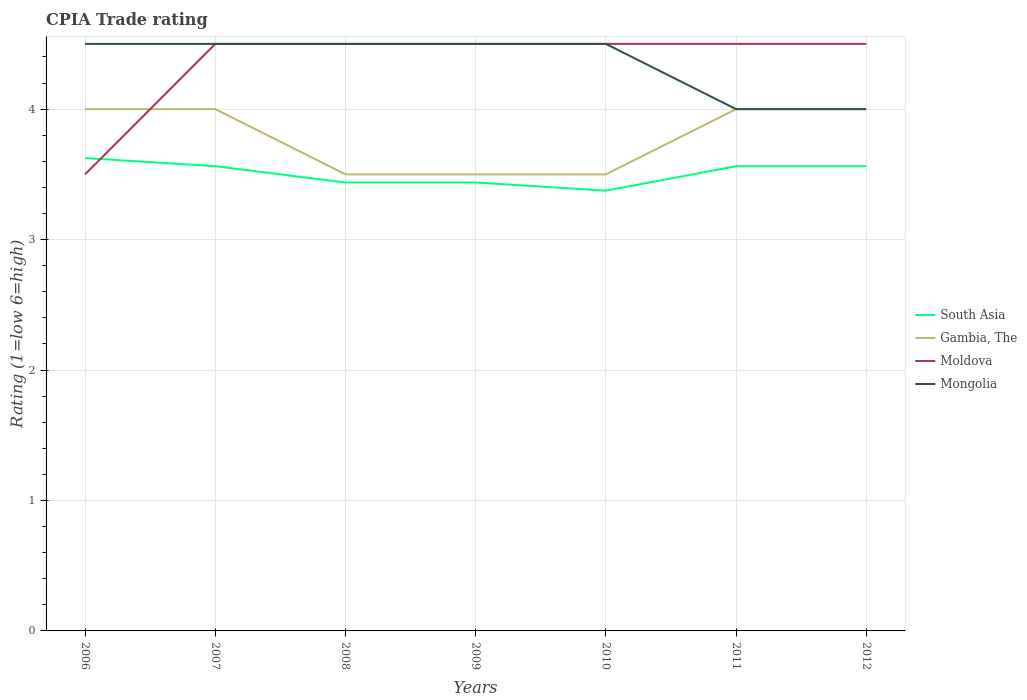Across all years, what is the maximum CPIA rating in Gambia, The?
Offer a very short reply. 3.5. In which year was the CPIA rating in Mongolia maximum?
Keep it short and to the point. 2011. What is the total CPIA rating in Mongolia in the graph?
Provide a succinct answer. 0. Is the CPIA rating in South Asia strictly greater than the CPIA rating in Mongolia over the years?
Give a very brief answer. Yes. How many lines are there?
Provide a succinct answer. 4. How many years are there in the graph?
Your answer should be compact. 7. What is the difference between two consecutive major ticks on the Y-axis?
Provide a succinct answer. 1. Are the values on the major ticks of Y-axis written in scientific E-notation?
Your answer should be very brief. No. What is the title of the graph?
Keep it short and to the point. CPIA Trade rating. Does "New Caledonia" appear as one of the legend labels in the graph?
Keep it short and to the point. No. What is the label or title of the X-axis?
Your response must be concise. Years. What is the Rating (1=low 6=high) of South Asia in 2006?
Provide a succinct answer. 3.62. What is the Rating (1=low 6=high) in South Asia in 2007?
Provide a short and direct response. 3.56. What is the Rating (1=low 6=high) in Moldova in 2007?
Give a very brief answer. 4.5. What is the Rating (1=low 6=high) in South Asia in 2008?
Provide a short and direct response. 3.44. What is the Rating (1=low 6=high) of Gambia, The in 2008?
Provide a short and direct response. 3.5. What is the Rating (1=low 6=high) of South Asia in 2009?
Your response must be concise. 3.44. What is the Rating (1=low 6=high) in Moldova in 2009?
Provide a succinct answer. 4.5. What is the Rating (1=low 6=high) of Mongolia in 2009?
Your answer should be compact. 4.5. What is the Rating (1=low 6=high) in South Asia in 2010?
Offer a very short reply. 3.38. What is the Rating (1=low 6=high) of South Asia in 2011?
Your response must be concise. 3.56. What is the Rating (1=low 6=high) in South Asia in 2012?
Provide a succinct answer. 3.56. What is the Rating (1=low 6=high) of Gambia, The in 2012?
Your answer should be very brief. 4. What is the Rating (1=low 6=high) in Mongolia in 2012?
Provide a short and direct response. 4. Across all years, what is the maximum Rating (1=low 6=high) of South Asia?
Keep it short and to the point. 3.62. Across all years, what is the maximum Rating (1=low 6=high) of Gambia, The?
Make the answer very short. 4. Across all years, what is the maximum Rating (1=low 6=high) of Moldova?
Provide a short and direct response. 4.5. Across all years, what is the minimum Rating (1=low 6=high) of South Asia?
Make the answer very short. 3.38. What is the total Rating (1=low 6=high) of South Asia in the graph?
Your response must be concise. 24.56. What is the total Rating (1=low 6=high) of Moldova in the graph?
Provide a succinct answer. 30.5. What is the total Rating (1=low 6=high) of Mongolia in the graph?
Give a very brief answer. 30.5. What is the difference between the Rating (1=low 6=high) in South Asia in 2006 and that in 2007?
Offer a terse response. 0.06. What is the difference between the Rating (1=low 6=high) in Moldova in 2006 and that in 2007?
Provide a short and direct response. -1. What is the difference between the Rating (1=low 6=high) in Mongolia in 2006 and that in 2007?
Offer a very short reply. 0. What is the difference between the Rating (1=low 6=high) of South Asia in 2006 and that in 2008?
Give a very brief answer. 0.19. What is the difference between the Rating (1=low 6=high) of Gambia, The in 2006 and that in 2008?
Keep it short and to the point. 0.5. What is the difference between the Rating (1=low 6=high) of South Asia in 2006 and that in 2009?
Keep it short and to the point. 0.19. What is the difference between the Rating (1=low 6=high) of Moldova in 2006 and that in 2009?
Keep it short and to the point. -1. What is the difference between the Rating (1=low 6=high) in Mongolia in 2006 and that in 2009?
Offer a terse response. 0. What is the difference between the Rating (1=low 6=high) of Moldova in 2006 and that in 2010?
Keep it short and to the point. -1. What is the difference between the Rating (1=low 6=high) in Mongolia in 2006 and that in 2010?
Provide a succinct answer. 0. What is the difference between the Rating (1=low 6=high) of South Asia in 2006 and that in 2011?
Make the answer very short. 0.06. What is the difference between the Rating (1=low 6=high) in Gambia, The in 2006 and that in 2011?
Provide a short and direct response. 0. What is the difference between the Rating (1=low 6=high) of Moldova in 2006 and that in 2011?
Make the answer very short. -1. What is the difference between the Rating (1=low 6=high) in South Asia in 2006 and that in 2012?
Ensure brevity in your answer.  0.06. What is the difference between the Rating (1=low 6=high) of Gambia, The in 2006 and that in 2012?
Provide a short and direct response. 0. What is the difference between the Rating (1=low 6=high) of Mongolia in 2006 and that in 2012?
Give a very brief answer. 0.5. What is the difference between the Rating (1=low 6=high) in South Asia in 2007 and that in 2008?
Provide a succinct answer. 0.12. What is the difference between the Rating (1=low 6=high) in Gambia, The in 2007 and that in 2008?
Offer a very short reply. 0.5. What is the difference between the Rating (1=low 6=high) in Moldova in 2007 and that in 2008?
Ensure brevity in your answer.  0. What is the difference between the Rating (1=low 6=high) in Moldova in 2007 and that in 2009?
Give a very brief answer. 0. What is the difference between the Rating (1=low 6=high) in Mongolia in 2007 and that in 2009?
Make the answer very short. 0. What is the difference between the Rating (1=low 6=high) in South Asia in 2007 and that in 2010?
Offer a terse response. 0.19. What is the difference between the Rating (1=low 6=high) of Gambia, The in 2007 and that in 2010?
Ensure brevity in your answer.  0.5. What is the difference between the Rating (1=low 6=high) of Moldova in 2007 and that in 2010?
Give a very brief answer. 0. What is the difference between the Rating (1=low 6=high) of Mongolia in 2007 and that in 2010?
Keep it short and to the point. 0. What is the difference between the Rating (1=low 6=high) of Gambia, The in 2007 and that in 2011?
Provide a succinct answer. 0. What is the difference between the Rating (1=low 6=high) of Moldova in 2007 and that in 2011?
Your response must be concise. 0. What is the difference between the Rating (1=low 6=high) of Mongolia in 2007 and that in 2011?
Your response must be concise. 0.5. What is the difference between the Rating (1=low 6=high) of South Asia in 2007 and that in 2012?
Keep it short and to the point. 0. What is the difference between the Rating (1=low 6=high) of Gambia, The in 2007 and that in 2012?
Keep it short and to the point. 0. What is the difference between the Rating (1=low 6=high) of South Asia in 2008 and that in 2009?
Provide a short and direct response. 0. What is the difference between the Rating (1=low 6=high) of Mongolia in 2008 and that in 2009?
Your answer should be very brief. 0. What is the difference between the Rating (1=low 6=high) in South Asia in 2008 and that in 2010?
Offer a very short reply. 0.06. What is the difference between the Rating (1=low 6=high) in South Asia in 2008 and that in 2011?
Your answer should be very brief. -0.12. What is the difference between the Rating (1=low 6=high) in Gambia, The in 2008 and that in 2011?
Your response must be concise. -0.5. What is the difference between the Rating (1=low 6=high) of Moldova in 2008 and that in 2011?
Your response must be concise. 0. What is the difference between the Rating (1=low 6=high) of Mongolia in 2008 and that in 2011?
Offer a terse response. 0.5. What is the difference between the Rating (1=low 6=high) in South Asia in 2008 and that in 2012?
Your response must be concise. -0.12. What is the difference between the Rating (1=low 6=high) of Gambia, The in 2008 and that in 2012?
Your response must be concise. -0.5. What is the difference between the Rating (1=low 6=high) of Mongolia in 2008 and that in 2012?
Your answer should be very brief. 0.5. What is the difference between the Rating (1=low 6=high) of South Asia in 2009 and that in 2010?
Keep it short and to the point. 0.06. What is the difference between the Rating (1=low 6=high) of Gambia, The in 2009 and that in 2010?
Provide a short and direct response. 0. What is the difference between the Rating (1=low 6=high) of Moldova in 2009 and that in 2010?
Provide a short and direct response. 0. What is the difference between the Rating (1=low 6=high) in Mongolia in 2009 and that in 2010?
Your answer should be very brief. 0. What is the difference between the Rating (1=low 6=high) of South Asia in 2009 and that in 2011?
Offer a very short reply. -0.12. What is the difference between the Rating (1=low 6=high) of South Asia in 2009 and that in 2012?
Keep it short and to the point. -0.12. What is the difference between the Rating (1=low 6=high) of Gambia, The in 2009 and that in 2012?
Your response must be concise. -0.5. What is the difference between the Rating (1=low 6=high) in Moldova in 2009 and that in 2012?
Provide a short and direct response. 0. What is the difference between the Rating (1=low 6=high) of South Asia in 2010 and that in 2011?
Your response must be concise. -0.19. What is the difference between the Rating (1=low 6=high) in Moldova in 2010 and that in 2011?
Give a very brief answer. 0. What is the difference between the Rating (1=low 6=high) of Mongolia in 2010 and that in 2011?
Your answer should be compact. 0.5. What is the difference between the Rating (1=low 6=high) of South Asia in 2010 and that in 2012?
Your answer should be compact. -0.19. What is the difference between the Rating (1=low 6=high) in Gambia, The in 2010 and that in 2012?
Make the answer very short. -0.5. What is the difference between the Rating (1=low 6=high) of Mongolia in 2010 and that in 2012?
Your answer should be very brief. 0.5. What is the difference between the Rating (1=low 6=high) of South Asia in 2011 and that in 2012?
Offer a very short reply. 0. What is the difference between the Rating (1=low 6=high) of South Asia in 2006 and the Rating (1=low 6=high) of Gambia, The in 2007?
Ensure brevity in your answer.  -0.38. What is the difference between the Rating (1=low 6=high) in South Asia in 2006 and the Rating (1=low 6=high) in Moldova in 2007?
Provide a short and direct response. -0.88. What is the difference between the Rating (1=low 6=high) in South Asia in 2006 and the Rating (1=low 6=high) in Mongolia in 2007?
Your answer should be compact. -0.88. What is the difference between the Rating (1=low 6=high) in South Asia in 2006 and the Rating (1=low 6=high) in Gambia, The in 2008?
Provide a short and direct response. 0.12. What is the difference between the Rating (1=low 6=high) in South Asia in 2006 and the Rating (1=low 6=high) in Moldova in 2008?
Keep it short and to the point. -0.88. What is the difference between the Rating (1=low 6=high) in South Asia in 2006 and the Rating (1=low 6=high) in Mongolia in 2008?
Offer a terse response. -0.88. What is the difference between the Rating (1=low 6=high) of Moldova in 2006 and the Rating (1=low 6=high) of Mongolia in 2008?
Your answer should be very brief. -1. What is the difference between the Rating (1=low 6=high) of South Asia in 2006 and the Rating (1=low 6=high) of Moldova in 2009?
Your answer should be compact. -0.88. What is the difference between the Rating (1=low 6=high) of South Asia in 2006 and the Rating (1=low 6=high) of Mongolia in 2009?
Offer a terse response. -0.88. What is the difference between the Rating (1=low 6=high) of South Asia in 2006 and the Rating (1=low 6=high) of Moldova in 2010?
Your response must be concise. -0.88. What is the difference between the Rating (1=low 6=high) in South Asia in 2006 and the Rating (1=low 6=high) in Mongolia in 2010?
Your answer should be very brief. -0.88. What is the difference between the Rating (1=low 6=high) of Gambia, The in 2006 and the Rating (1=low 6=high) of Mongolia in 2010?
Your answer should be very brief. -0.5. What is the difference between the Rating (1=low 6=high) of South Asia in 2006 and the Rating (1=low 6=high) of Gambia, The in 2011?
Give a very brief answer. -0.38. What is the difference between the Rating (1=low 6=high) of South Asia in 2006 and the Rating (1=low 6=high) of Moldova in 2011?
Offer a terse response. -0.88. What is the difference between the Rating (1=low 6=high) of South Asia in 2006 and the Rating (1=low 6=high) of Mongolia in 2011?
Give a very brief answer. -0.38. What is the difference between the Rating (1=low 6=high) of Gambia, The in 2006 and the Rating (1=low 6=high) of Mongolia in 2011?
Make the answer very short. 0. What is the difference between the Rating (1=low 6=high) of South Asia in 2006 and the Rating (1=low 6=high) of Gambia, The in 2012?
Your response must be concise. -0.38. What is the difference between the Rating (1=low 6=high) in South Asia in 2006 and the Rating (1=low 6=high) in Moldova in 2012?
Make the answer very short. -0.88. What is the difference between the Rating (1=low 6=high) in South Asia in 2006 and the Rating (1=low 6=high) in Mongolia in 2012?
Offer a very short reply. -0.38. What is the difference between the Rating (1=low 6=high) of South Asia in 2007 and the Rating (1=low 6=high) of Gambia, The in 2008?
Provide a short and direct response. 0.06. What is the difference between the Rating (1=low 6=high) of South Asia in 2007 and the Rating (1=low 6=high) of Moldova in 2008?
Make the answer very short. -0.94. What is the difference between the Rating (1=low 6=high) in South Asia in 2007 and the Rating (1=low 6=high) in Mongolia in 2008?
Your answer should be compact. -0.94. What is the difference between the Rating (1=low 6=high) of Gambia, The in 2007 and the Rating (1=low 6=high) of Mongolia in 2008?
Your response must be concise. -0.5. What is the difference between the Rating (1=low 6=high) of Moldova in 2007 and the Rating (1=low 6=high) of Mongolia in 2008?
Give a very brief answer. 0. What is the difference between the Rating (1=low 6=high) of South Asia in 2007 and the Rating (1=low 6=high) of Gambia, The in 2009?
Keep it short and to the point. 0.06. What is the difference between the Rating (1=low 6=high) in South Asia in 2007 and the Rating (1=low 6=high) in Moldova in 2009?
Provide a short and direct response. -0.94. What is the difference between the Rating (1=low 6=high) in South Asia in 2007 and the Rating (1=low 6=high) in Mongolia in 2009?
Keep it short and to the point. -0.94. What is the difference between the Rating (1=low 6=high) of Gambia, The in 2007 and the Rating (1=low 6=high) of Moldova in 2009?
Offer a terse response. -0.5. What is the difference between the Rating (1=low 6=high) in South Asia in 2007 and the Rating (1=low 6=high) in Gambia, The in 2010?
Offer a very short reply. 0.06. What is the difference between the Rating (1=low 6=high) in South Asia in 2007 and the Rating (1=low 6=high) in Moldova in 2010?
Your answer should be compact. -0.94. What is the difference between the Rating (1=low 6=high) in South Asia in 2007 and the Rating (1=low 6=high) in Mongolia in 2010?
Keep it short and to the point. -0.94. What is the difference between the Rating (1=low 6=high) in Gambia, The in 2007 and the Rating (1=low 6=high) in Moldova in 2010?
Offer a very short reply. -0.5. What is the difference between the Rating (1=low 6=high) of South Asia in 2007 and the Rating (1=low 6=high) of Gambia, The in 2011?
Keep it short and to the point. -0.44. What is the difference between the Rating (1=low 6=high) of South Asia in 2007 and the Rating (1=low 6=high) of Moldova in 2011?
Ensure brevity in your answer.  -0.94. What is the difference between the Rating (1=low 6=high) in South Asia in 2007 and the Rating (1=low 6=high) in Mongolia in 2011?
Provide a succinct answer. -0.44. What is the difference between the Rating (1=low 6=high) in Gambia, The in 2007 and the Rating (1=low 6=high) in Moldova in 2011?
Your answer should be very brief. -0.5. What is the difference between the Rating (1=low 6=high) of Gambia, The in 2007 and the Rating (1=low 6=high) of Mongolia in 2011?
Offer a terse response. 0. What is the difference between the Rating (1=low 6=high) in Moldova in 2007 and the Rating (1=low 6=high) in Mongolia in 2011?
Give a very brief answer. 0.5. What is the difference between the Rating (1=low 6=high) in South Asia in 2007 and the Rating (1=low 6=high) in Gambia, The in 2012?
Make the answer very short. -0.44. What is the difference between the Rating (1=low 6=high) in South Asia in 2007 and the Rating (1=low 6=high) in Moldova in 2012?
Ensure brevity in your answer.  -0.94. What is the difference between the Rating (1=low 6=high) of South Asia in 2007 and the Rating (1=low 6=high) of Mongolia in 2012?
Provide a short and direct response. -0.44. What is the difference between the Rating (1=low 6=high) of Gambia, The in 2007 and the Rating (1=low 6=high) of Moldova in 2012?
Provide a succinct answer. -0.5. What is the difference between the Rating (1=low 6=high) of Gambia, The in 2007 and the Rating (1=low 6=high) of Mongolia in 2012?
Your answer should be compact. 0. What is the difference between the Rating (1=low 6=high) in South Asia in 2008 and the Rating (1=low 6=high) in Gambia, The in 2009?
Give a very brief answer. -0.06. What is the difference between the Rating (1=low 6=high) in South Asia in 2008 and the Rating (1=low 6=high) in Moldova in 2009?
Offer a terse response. -1.06. What is the difference between the Rating (1=low 6=high) of South Asia in 2008 and the Rating (1=low 6=high) of Mongolia in 2009?
Ensure brevity in your answer.  -1.06. What is the difference between the Rating (1=low 6=high) in Gambia, The in 2008 and the Rating (1=low 6=high) in Moldova in 2009?
Ensure brevity in your answer.  -1. What is the difference between the Rating (1=low 6=high) of Gambia, The in 2008 and the Rating (1=low 6=high) of Mongolia in 2009?
Provide a succinct answer. -1. What is the difference between the Rating (1=low 6=high) of South Asia in 2008 and the Rating (1=low 6=high) of Gambia, The in 2010?
Provide a short and direct response. -0.06. What is the difference between the Rating (1=low 6=high) in South Asia in 2008 and the Rating (1=low 6=high) in Moldova in 2010?
Provide a short and direct response. -1.06. What is the difference between the Rating (1=low 6=high) in South Asia in 2008 and the Rating (1=low 6=high) in Mongolia in 2010?
Provide a short and direct response. -1.06. What is the difference between the Rating (1=low 6=high) of Gambia, The in 2008 and the Rating (1=low 6=high) of Moldova in 2010?
Keep it short and to the point. -1. What is the difference between the Rating (1=low 6=high) in Gambia, The in 2008 and the Rating (1=low 6=high) in Mongolia in 2010?
Give a very brief answer. -1. What is the difference between the Rating (1=low 6=high) of Moldova in 2008 and the Rating (1=low 6=high) of Mongolia in 2010?
Give a very brief answer. 0. What is the difference between the Rating (1=low 6=high) of South Asia in 2008 and the Rating (1=low 6=high) of Gambia, The in 2011?
Offer a terse response. -0.56. What is the difference between the Rating (1=low 6=high) in South Asia in 2008 and the Rating (1=low 6=high) in Moldova in 2011?
Your answer should be very brief. -1.06. What is the difference between the Rating (1=low 6=high) of South Asia in 2008 and the Rating (1=low 6=high) of Mongolia in 2011?
Provide a succinct answer. -0.56. What is the difference between the Rating (1=low 6=high) in Gambia, The in 2008 and the Rating (1=low 6=high) in Mongolia in 2011?
Provide a short and direct response. -0.5. What is the difference between the Rating (1=low 6=high) in South Asia in 2008 and the Rating (1=low 6=high) in Gambia, The in 2012?
Offer a terse response. -0.56. What is the difference between the Rating (1=low 6=high) in South Asia in 2008 and the Rating (1=low 6=high) in Moldova in 2012?
Provide a short and direct response. -1.06. What is the difference between the Rating (1=low 6=high) in South Asia in 2008 and the Rating (1=low 6=high) in Mongolia in 2012?
Ensure brevity in your answer.  -0.56. What is the difference between the Rating (1=low 6=high) in Gambia, The in 2008 and the Rating (1=low 6=high) in Moldova in 2012?
Offer a terse response. -1. What is the difference between the Rating (1=low 6=high) of Moldova in 2008 and the Rating (1=low 6=high) of Mongolia in 2012?
Provide a short and direct response. 0.5. What is the difference between the Rating (1=low 6=high) in South Asia in 2009 and the Rating (1=low 6=high) in Gambia, The in 2010?
Your answer should be compact. -0.06. What is the difference between the Rating (1=low 6=high) in South Asia in 2009 and the Rating (1=low 6=high) in Moldova in 2010?
Offer a very short reply. -1.06. What is the difference between the Rating (1=low 6=high) of South Asia in 2009 and the Rating (1=low 6=high) of Mongolia in 2010?
Make the answer very short. -1.06. What is the difference between the Rating (1=low 6=high) of Gambia, The in 2009 and the Rating (1=low 6=high) of Moldova in 2010?
Offer a terse response. -1. What is the difference between the Rating (1=low 6=high) of Moldova in 2009 and the Rating (1=low 6=high) of Mongolia in 2010?
Offer a terse response. 0. What is the difference between the Rating (1=low 6=high) of South Asia in 2009 and the Rating (1=low 6=high) of Gambia, The in 2011?
Keep it short and to the point. -0.56. What is the difference between the Rating (1=low 6=high) of South Asia in 2009 and the Rating (1=low 6=high) of Moldova in 2011?
Provide a short and direct response. -1.06. What is the difference between the Rating (1=low 6=high) of South Asia in 2009 and the Rating (1=low 6=high) of Mongolia in 2011?
Offer a terse response. -0.56. What is the difference between the Rating (1=low 6=high) of Gambia, The in 2009 and the Rating (1=low 6=high) of Moldova in 2011?
Offer a very short reply. -1. What is the difference between the Rating (1=low 6=high) in Moldova in 2009 and the Rating (1=low 6=high) in Mongolia in 2011?
Offer a terse response. 0.5. What is the difference between the Rating (1=low 6=high) of South Asia in 2009 and the Rating (1=low 6=high) of Gambia, The in 2012?
Your answer should be compact. -0.56. What is the difference between the Rating (1=low 6=high) in South Asia in 2009 and the Rating (1=low 6=high) in Moldova in 2012?
Give a very brief answer. -1.06. What is the difference between the Rating (1=low 6=high) in South Asia in 2009 and the Rating (1=low 6=high) in Mongolia in 2012?
Provide a short and direct response. -0.56. What is the difference between the Rating (1=low 6=high) in Gambia, The in 2009 and the Rating (1=low 6=high) in Mongolia in 2012?
Offer a terse response. -0.5. What is the difference between the Rating (1=low 6=high) in Moldova in 2009 and the Rating (1=low 6=high) in Mongolia in 2012?
Provide a succinct answer. 0.5. What is the difference between the Rating (1=low 6=high) in South Asia in 2010 and the Rating (1=low 6=high) in Gambia, The in 2011?
Offer a very short reply. -0.62. What is the difference between the Rating (1=low 6=high) in South Asia in 2010 and the Rating (1=low 6=high) in Moldova in 2011?
Keep it short and to the point. -1.12. What is the difference between the Rating (1=low 6=high) of South Asia in 2010 and the Rating (1=low 6=high) of Mongolia in 2011?
Your response must be concise. -0.62. What is the difference between the Rating (1=low 6=high) of Moldova in 2010 and the Rating (1=low 6=high) of Mongolia in 2011?
Offer a terse response. 0.5. What is the difference between the Rating (1=low 6=high) in South Asia in 2010 and the Rating (1=low 6=high) in Gambia, The in 2012?
Your response must be concise. -0.62. What is the difference between the Rating (1=low 6=high) of South Asia in 2010 and the Rating (1=low 6=high) of Moldova in 2012?
Your response must be concise. -1.12. What is the difference between the Rating (1=low 6=high) of South Asia in 2010 and the Rating (1=low 6=high) of Mongolia in 2012?
Your answer should be very brief. -0.62. What is the difference between the Rating (1=low 6=high) of Gambia, The in 2010 and the Rating (1=low 6=high) of Mongolia in 2012?
Offer a very short reply. -0.5. What is the difference between the Rating (1=low 6=high) of South Asia in 2011 and the Rating (1=low 6=high) of Gambia, The in 2012?
Give a very brief answer. -0.44. What is the difference between the Rating (1=low 6=high) in South Asia in 2011 and the Rating (1=low 6=high) in Moldova in 2012?
Make the answer very short. -0.94. What is the difference between the Rating (1=low 6=high) of South Asia in 2011 and the Rating (1=low 6=high) of Mongolia in 2012?
Offer a terse response. -0.44. What is the average Rating (1=low 6=high) of South Asia per year?
Make the answer very short. 3.51. What is the average Rating (1=low 6=high) of Gambia, The per year?
Offer a very short reply. 3.79. What is the average Rating (1=low 6=high) in Moldova per year?
Offer a terse response. 4.36. What is the average Rating (1=low 6=high) of Mongolia per year?
Your answer should be compact. 4.36. In the year 2006, what is the difference between the Rating (1=low 6=high) of South Asia and Rating (1=low 6=high) of Gambia, The?
Make the answer very short. -0.38. In the year 2006, what is the difference between the Rating (1=low 6=high) in South Asia and Rating (1=low 6=high) in Mongolia?
Offer a very short reply. -0.88. In the year 2006, what is the difference between the Rating (1=low 6=high) in Gambia, The and Rating (1=low 6=high) in Mongolia?
Provide a succinct answer. -0.5. In the year 2007, what is the difference between the Rating (1=low 6=high) of South Asia and Rating (1=low 6=high) of Gambia, The?
Ensure brevity in your answer.  -0.44. In the year 2007, what is the difference between the Rating (1=low 6=high) in South Asia and Rating (1=low 6=high) in Moldova?
Make the answer very short. -0.94. In the year 2007, what is the difference between the Rating (1=low 6=high) in South Asia and Rating (1=low 6=high) in Mongolia?
Provide a short and direct response. -0.94. In the year 2007, what is the difference between the Rating (1=low 6=high) in Gambia, The and Rating (1=low 6=high) in Moldova?
Ensure brevity in your answer.  -0.5. In the year 2008, what is the difference between the Rating (1=low 6=high) in South Asia and Rating (1=low 6=high) in Gambia, The?
Provide a short and direct response. -0.06. In the year 2008, what is the difference between the Rating (1=low 6=high) in South Asia and Rating (1=low 6=high) in Moldova?
Offer a very short reply. -1.06. In the year 2008, what is the difference between the Rating (1=low 6=high) in South Asia and Rating (1=low 6=high) in Mongolia?
Offer a terse response. -1.06. In the year 2008, what is the difference between the Rating (1=low 6=high) of Moldova and Rating (1=low 6=high) of Mongolia?
Provide a succinct answer. 0. In the year 2009, what is the difference between the Rating (1=low 6=high) of South Asia and Rating (1=low 6=high) of Gambia, The?
Make the answer very short. -0.06. In the year 2009, what is the difference between the Rating (1=low 6=high) of South Asia and Rating (1=low 6=high) of Moldova?
Offer a terse response. -1.06. In the year 2009, what is the difference between the Rating (1=low 6=high) of South Asia and Rating (1=low 6=high) of Mongolia?
Provide a short and direct response. -1.06. In the year 2009, what is the difference between the Rating (1=low 6=high) in Gambia, The and Rating (1=low 6=high) in Mongolia?
Your answer should be very brief. -1. In the year 2010, what is the difference between the Rating (1=low 6=high) in South Asia and Rating (1=low 6=high) in Gambia, The?
Give a very brief answer. -0.12. In the year 2010, what is the difference between the Rating (1=low 6=high) in South Asia and Rating (1=low 6=high) in Moldova?
Your answer should be very brief. -1.12. In the year 2010, what is the difference between the Rating (1=low 6=high) in South Asia and Rating (1=low 6=high) in Mongolia?
Your response must be concise. -1.12. In the year 2010, what is the difference between the Rating (1=low 6=high) in Gambia, The and Rating (1=low 6=high) in Moldova?
Provide a short and direct response. -1. In the year 2010, what is the difference between the Rating (1=low 6=high) of Gambia, The and Rating (1=low 6=high) of Mongolia?
Ensure brevity in your answer.  -1. In the year 2011, what is the difference between the Rating (1=low 6=high) of South Asia and Rating (1=low 6=high) of Gambia, The?
Ensure brevity in your answer.  -0.44. In the year 2011, what is the difference between the Rating (1=low 6=high) in South Asia and Rating (1=low 6=high) in Moldova?
Keep it short and to the point. -0.94. In the year 2011, what is the difference between the Rating (1=low 6=high) in South Asia and Rating (1=low 6=high) in Mongolia?
Provide a short and direct response. -0.44. In the year 2011, what is the difference between the Rating (1=low 6=high) of Gambia, The and Rating (1=low 6=high) of Moldova?
Your answer should be compact. -0.5. In the year 2012, what is the difference between the Rating (1=low 6=high) of South Asia and Rating (1=low 6=high) of Gambia, The?
Your answer should be compact. -0.44. In the year 2012, what is the difference between the Rating (1=low 6=high) of South Asia and Rating (1=low 6=high) of Moldova?
Your answer should be compact. -0.94. In the year 2012, what is the difference between the Rating (1=low 6=high) of South Asia and Rating (1=low 6=high) of Mongolia?
Offer a very short reply. -0.44. In the year 2012, what is the difference between the Rating (1=low 6=high) of Gambia, The and Rating (1=low 6=high) of Mongolia?
Offer a very short reply. 0. What is the ratio of the Rating (1=low 6=high) of South Asia in 2006 to that in 2007?
Your response must be concise. 1.02. What is the ratio of the Rating (1=low 6=high) in Gambia, The in 2006 to that in 2007?
Provide a succinct answer. 1. What is the ratio of the Rating (1=low 6=high) of Mongolia in 2006 to that in 2007?
Offer a terse response. 1. What is the ratio of the Rating (1=low 6=high) in South Asia in 2006 to that in 2008?
Ensure brevity in your answer.  1.05. What is the ratio of the Rating (1=low 6=high) in Moldova in 2006 to that in 2008?
Give a very brief answer. 0.78. What is the ratio of the Rating (1=low 6=high) in Mongolia in 2006 to that in 2008?
Provide a short and direct response. 1. What is the ratio of the Rating (1=low 6=high) in South Asia in 2006 to that in 2009?
Provide a succinct answer. 1.05. What is the ratio of the Rating (1=low 6=high) of Gambia, The in 2006 to that in 2009?
Give a very brief answer. 1.14. What is the ratio of the Rating (1=low 6=high) in South Asia in 2006 to that in 2010?
Your answer should be compact. 1.07. What is the ratio of the Rating (1=low 6=high) of Moldova in 2006 to that in 2010?
Make the answer very short. 0.78. What is the ratio of the Rating (1=low 6=high) in South Asia in 2006 to that in 2011?
Offer a very short reply. 1.02. What is the ratio of the Rating (1=low 6=high) in Gambia, The in 2006 to that in 2011?
Keep it short and to the point. 1. What is the ratio of the Rating (1=low 6=high) of Moldova in 2006 to that in 2011?
Provide a short and direct response. 0.78. What is the ratio of the Rating (1=low 6=high) of South Asia in 2006 to that in 2012?
Provide a succinct answer. 1.02. What is the ratio of the Rating (1=low 6=high) of Gambia, The in 2006 to that in 2012?
Keep it short and to the point. 1. What is the ratio of the Rating (1=low 6=high) of South Asia in 2007 to that in 2008?
Offer a terse response. 1.04. What is the ratio of the Rating (1=low 6=high) in Moldova in 2007 to that in 2008?
Your response must be concise. 1. What is the ratio of the Rating (1=low 6=high) of Mongolia in 2007 to that in 2008?
Your answer should be compact. 1. What is the ratio of the Rating (1=low 6=high) in South Asia in 2007 to that in 2009?
Your answer should be very brief. 1.04. What is the ratio of the Rating (1=low 6=high) in Gambia, The in 2007 to that in 2009?
Your response must be concise. 1.14. What is the ratio of the Rating (1=low 6=high) in Mongolia in 2007 to that in 2009?
Provide a short and direct response. 1. What is the ratio of the Rating (1=low 6=high) in South Asia in 2007 to that in 2010?
Your answer should be very brief. 1.06. What is the ratio of the Rating (1=low 6=high) of Moldova in 2007 to that in 2010?
Your answer should be compact. 1. What is the ratio of the Rating (1=low 6=high) of Moldova in 2007 to that in 2011?
Keep it short and to the point. 1. What is the ratio of the Rating (1=low 6=high) of Mongolia in 2007 to that in 2011?
Your answer should be very brief. 1.12. What is the ratio of the Rating (1=low 6=high) of South Asia in 2007 to that in 2012?
Provide a short and direct response. 1. What is the ratio of the Rating (1=low 6=high) in Mongolia in 2007 to that in 2012?
Offer a very short reply. 1.12. What is the ratio of the Rating (1=low 6=high) in South Asia in 2008 to that in 2009?
Provide a short and direct response. 1. What is the ratio of the Rating (1=low 6=high) of Moldova in 2008 to that in 2009?
Give a very brief answer. 1. What is the ratio of the Rating (1=low 6=high) of Mongolia in 2008 to that in 2009?
Your answer should be very brief. 1. What is the ratio of the Rating (1=low 6=high) of South Asia in 2008 to that in 2010?
Your answer should be very brief. 1.02. What is the ratio of the Rating (1=low 6=high) of Moldova in 2008 to that in 2010?
Provide a succinct answer. 1. What is the ratio of the Rating (1=low 6=high) of Mongolia in 2008 to that in 2010?
Provide a short and direct response. 1. What is the ratio of the Rating (1=low 6=high) of South Asia in 2008 to that in 2011?
Keep it short and to the point. 0.96. What is the ratio of the Rating (1=low 6=high) of South Asia in 2008 to that in 2012?
Provide a short and direct response. 0.96. What is the ratio of the Rating (1=low 6=high) of Moldova in 2008 to that in 2012?
Provide a short and direct response. 1. What is the ratio of the Rating (1=low 6=high) of Mongolia in 2008 to that in 2012?
Offer a very short reply. 1.12. What is the ratio of the Rating (1=low 6=high) of South Asia in 2009 to that in 2010?
Offer a terse response. 1.02. What is the ratio of the Rating (1=low 6=high) in Gambia, The in 2009 to that in 2010?
Keep it short and to the point. 1. What is the ratio of the Rating (1=low 6=high) of South Asia in 2009 to that in 2011?
Provide a succinct answer. 0.96. What is the ratio of the Rating (1=low 6=high) in Gambia, The in 2009 to that in 2011?
Your answer should be very brief. 0.88. What is the ratio of the Rating (1=low 6=high) in Moldova in 2009 to that in 2011?
Your answer should be very brief. 1. What is the ratio of the Rating (1=low 6=high) in South Asia in 2009 to that in 2012?
Your answer should be very brief. 0.96. What is the ratio of the Rating (1=low 6=high) of Gambia, The in 2009 to that in 2012?
Keep it short and to the point. 0.88. What is the ratio of the Rating (1=low 6=high) of South Asia in 2010 to that in 2011?
Provide a short and direct response. 0.95. What is the ratio of the Rating (1=low 6=high) of Mongolia in 2010 to that in 2011?
Keep it short and to the point. 1.12. What is the ratio of the Rating (1=low 6=high) in South Asia in 2010 to that in 2012?
Make the answer very short. 0.95. What is the ratio of the Rating (1=low 6=high) of Gambia, The in 2010 to that in 2012?
Provide a succinct answer. 0.88. What is the ratio of the Rating (1=low 6=high) of Moldova in 2010 to that in 2012?
Provide a succinct answer. 1. What is the ratio of the Rating (1=low 6=high) of Mongolia in 2011 to that in 2012?
Your answer should be very brief. 1. What is the difference between the highest and the second highest Rating (1=low 6=high) of South Asia?
Offer a terse response. 0.06. What is the difference between the highest and the second highest Rating (1=low 6=high) of Moldova?
Ensure brevity in your answer.  0. What is the difference between the highest and the lowest Rating (1=low 6=high) of Gambia, The?
Provide a succinct answer. 0.5. What is the difference between the highest and the lowest Rating (1=low 6=high) of Mongolia?
Offer a very short reply. 0.5. 